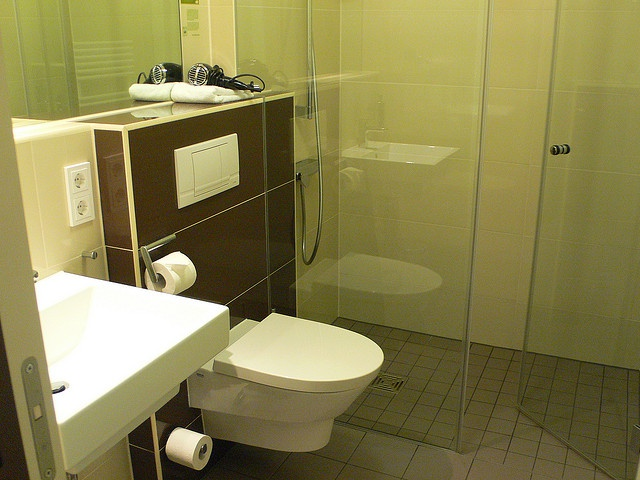Describe the objects in this image and their specific colors. I can see sink in khaki, white, beige, gray, and black tones, toilet in khaki, gray, and olive tones, toilet in khaki, beige, darkgreen, and black tones, and hair drier in khaki, black, gray, darkgreen, and olive tones in this image. 